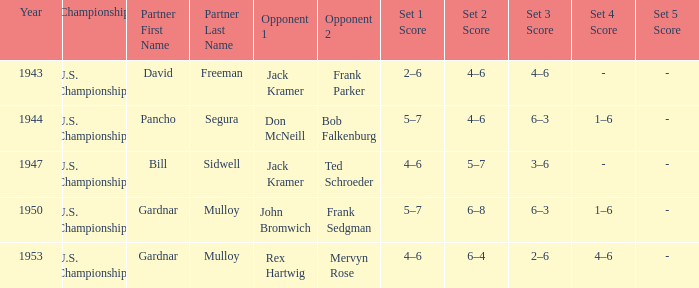Which Year has a Score of 5–7, 4–6, 6–3, 1–6? 1944.0. 